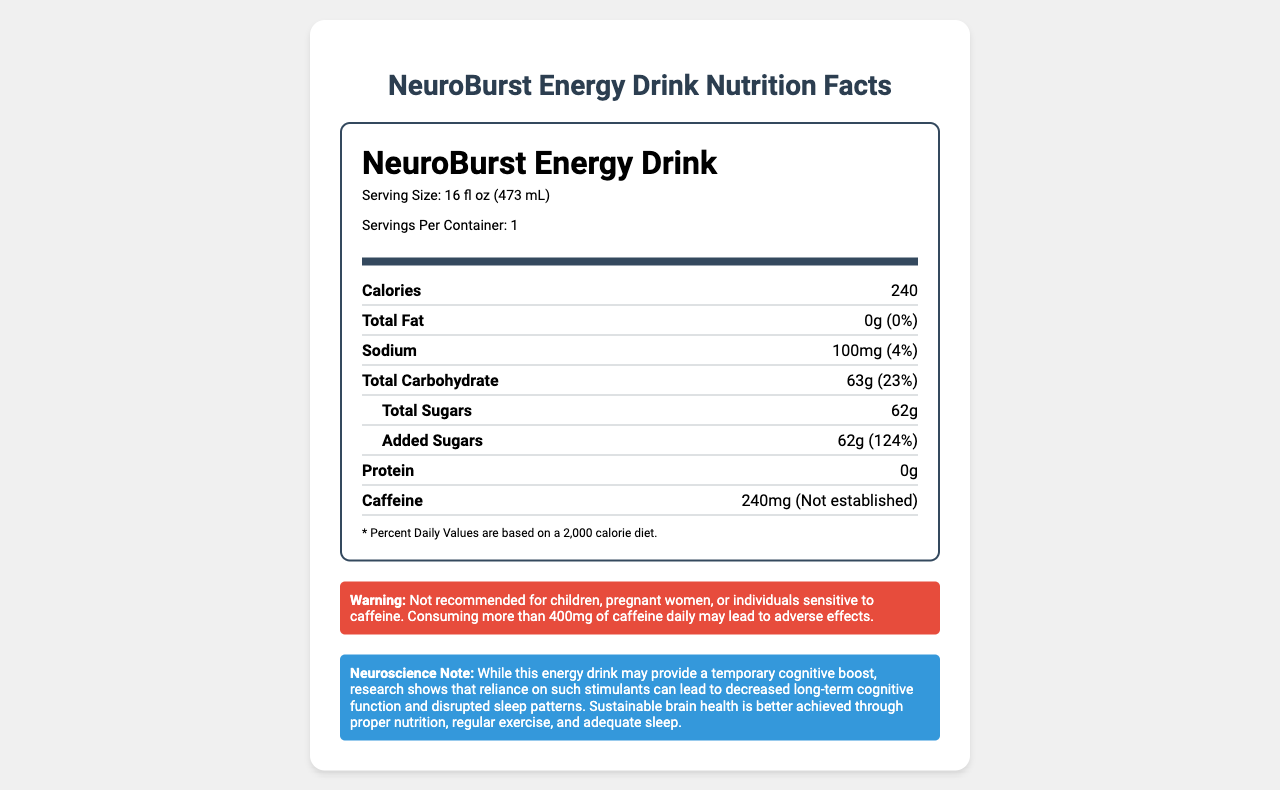what is the serving size of NeuroBurst Energy Drink? The document specifies the serving size as 16 fl oz (473 mL).
Answer: 16 fl oz (473 mL) how many calories are in one serving of NeuroBurst Energy Drink? The document lists the calorie content as 240 per serving.
Answer: 240 what is the total fat content in the drink? The document indicates that the total fat content is 0g.
Answer: 0g what percentage of the daily value of sodium does this drink contain? The document states that the sodium content is 100mg, which is 4% of the daily value.
Answer: 4% how much caffeine is in the NeuroBurst Energy Drink? The document details the caffeine content as 240mg.
Answer: 240mg what is the daily value percentage for Vitamin B6 in the drink? According to the document, Vitamin B6 content is 118% of the daily value.
Answer: 118% what are the first three ingredients listed in the drink? The document lists the first three ingredients as Carbonated Water, High Fructose Corn Syrup, and Citric Acid.
Answer: Carbonated Water, High Fructose Corn Syrup, Citric Acid what is the warning associated with this drink? The document contains a warning stating that the drink is not recommended for certain individuals and advises against consuming more than 400mg of caffeine daily.
Answer: Not recommended for children, pregnant women, or individuals sensitive to caffeine. Consuming more than 400mg of caffeine daily may lead to adverse effects. what is the percentage of added sugars in the daily value? The document states that the added sugars amount to 124% of the daily value.
Answer: 124% what does the neuroscience note suggest about the use of this energy drink? The document suggests that while the drink may temporarily boost cognition, long-term usage can affect cognitive function and sleep.
Answer: It may provide a temporary cognitive boost but reliance on such stimulants can lead to decreased long-term cognitive function and disrupted sleep patterns. how many vitamins and minerals are listed on the label? The document lists three vitamins and minerals: Vitamin B6, Vitamin B12, and Niacin.
Answer: Three which vitamin has the highest daily value percentage? A. Vitamin B6 B. Vitamin B12 C. Niacin Vitamin B12 has a daily value percentage of 250%, which is higher than Vitamin B6 (118%) and Niacin (125%).
Answer: B what is the total carbohydrate content in one serving? The document lists the total carbohydrate content as 63g.
Answer: 63g which of the following is not an ingredient listed in the drink? A. Guarana Extract B. Sodium Citrate C. Green Tea Extract The document lists Guarana Extract and Sodium Citrate as ingredients, but not Green Tea Extract.
Answer: C does the label suggest that the drink contains any protein? The document explicitly states that the protein content is 0g.
Answer: No summarize the main nutritional concerns highlighted in the document. The document highlights the high sugar and caffeine content and provides warnings and potential long-term health impacts.
Answer: The NeuroBurst Energy Drink contains high amounts of sugar (62g, 124% DV for added sugars) and caffeine (240mg), with warnings against its use by children, pregnant women, and individuals sensitive to caffeine. It also notes the potential negative impact on long-term cognitive function and sleep patterns. are the daily values for the nutrients based on a 2,000 calorie diet? The document includes a note that states the Percent Daily Values are based on a 2,000 calorie diet.
Answer: Yes what flavor is the NeuroBurst Energy Drink? The document does not provide information about the flavor of the energy drink.
Answer: Not enough information 